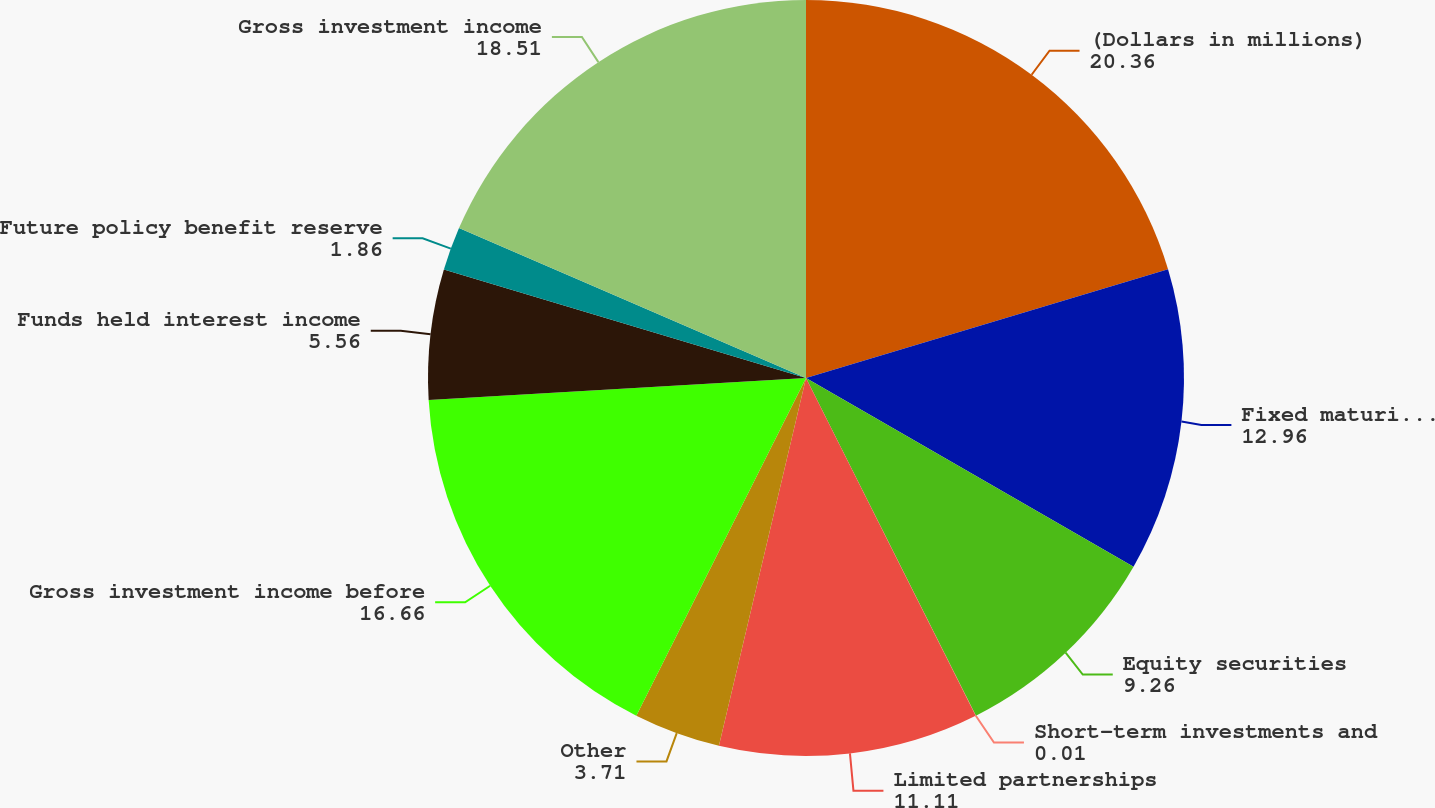Convert chart to OTSL. <chart><loc_0><loc_0><loc_500><loc_500><pie_chart><fcel>(Dollars in millions)<fcel>Fixed maturities<fcel>Equity securities<fcel>Short-term investments and<fcel>Limited partnerships<fcel>Other<fcel>Gross investment income before<fcel>Funds held interest income<fcel>Future policy benefit reserve<fcel>Gross investment income<nl><fcel>20.36%<fcel>12.96%<fcel>9.26%<fcel>0.01%<fcel>11.11%<fcel>3.71%<fcel>16.66%<fcel>5.56%<fcel>1.86%<fcel>18.51%<nl></chart> 